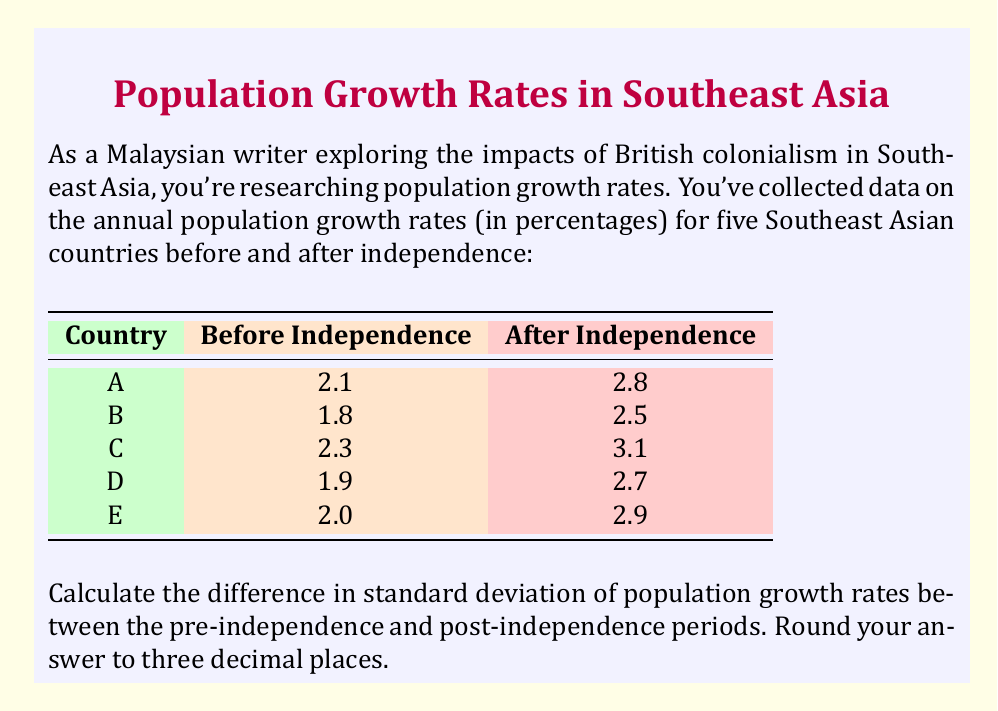Can you answer this question? To solve this problem, we need to calculate the standard deviation for both periods and then find their difference. Let's follow these steps:

1. Calculate the mean for each period:

   Before Independence: $\mu_1 = \frac{2.1 + 1.8 + 2.3 + 1.9 + 2.0}{5} = 2.02$
   After Independence: $\mu_2 = \frac{2.8 + 2.5 + 3.1 + 2.7 + 2.9}{5} = 2.80$

2. Calculate the squared differences from the mean for each period:

   Before Independence:
   $(2.1 - 2.02)^2 = 0.0064$
   $(1.8 - 2.02)^2 = 0.0484$
   $(2.3 - 2.02)^2 = 0.0784$
   $(1.9 - 2.02)^2 = 0.0144$
   $(2.0 - 2.02)^2 = 0.0004$

   After Independence:
   $(2.8 - 2.80)^2 = 0.0000$
   $(2.5 - 2.80)^2 = 0.0900$
   $(3.1 - 2.80)^2 = 0.0900$
   $(2.7 - 2.80)^2 = 0.0100$
   $(2.9 - 2.80)^2 = 0.0100$

3. Calculate the variance for each period:

   Before Independence: $\sigma_1^2 = \frac{0.0064 + 0.0484 + 0.0784 + 0.0144 + 0.0004}{5} = 0.0296$
   After Independence: $\sigma_2^2 = \frac{0.0000 + 0.0900 + 0.0900 + 0.0100 + 0.0100}{5} = 0.0400$

4. Calculate the standard deviation for each period:

   Before Independence: $\sigma_1 = \sqrt{0.0296} \approx 0.172$
   After Independence: $\sigma_2 = \sqrt{0.0400} = 0.200$

5. Calculate the difference in standard deviations:

   $\Delta\sigma = \sigma_2 - \sigma_1 = 0.200 - 0.172 = 0.028$

Rounding to three decimal places, we get 0.028.
Answer: 0.028 